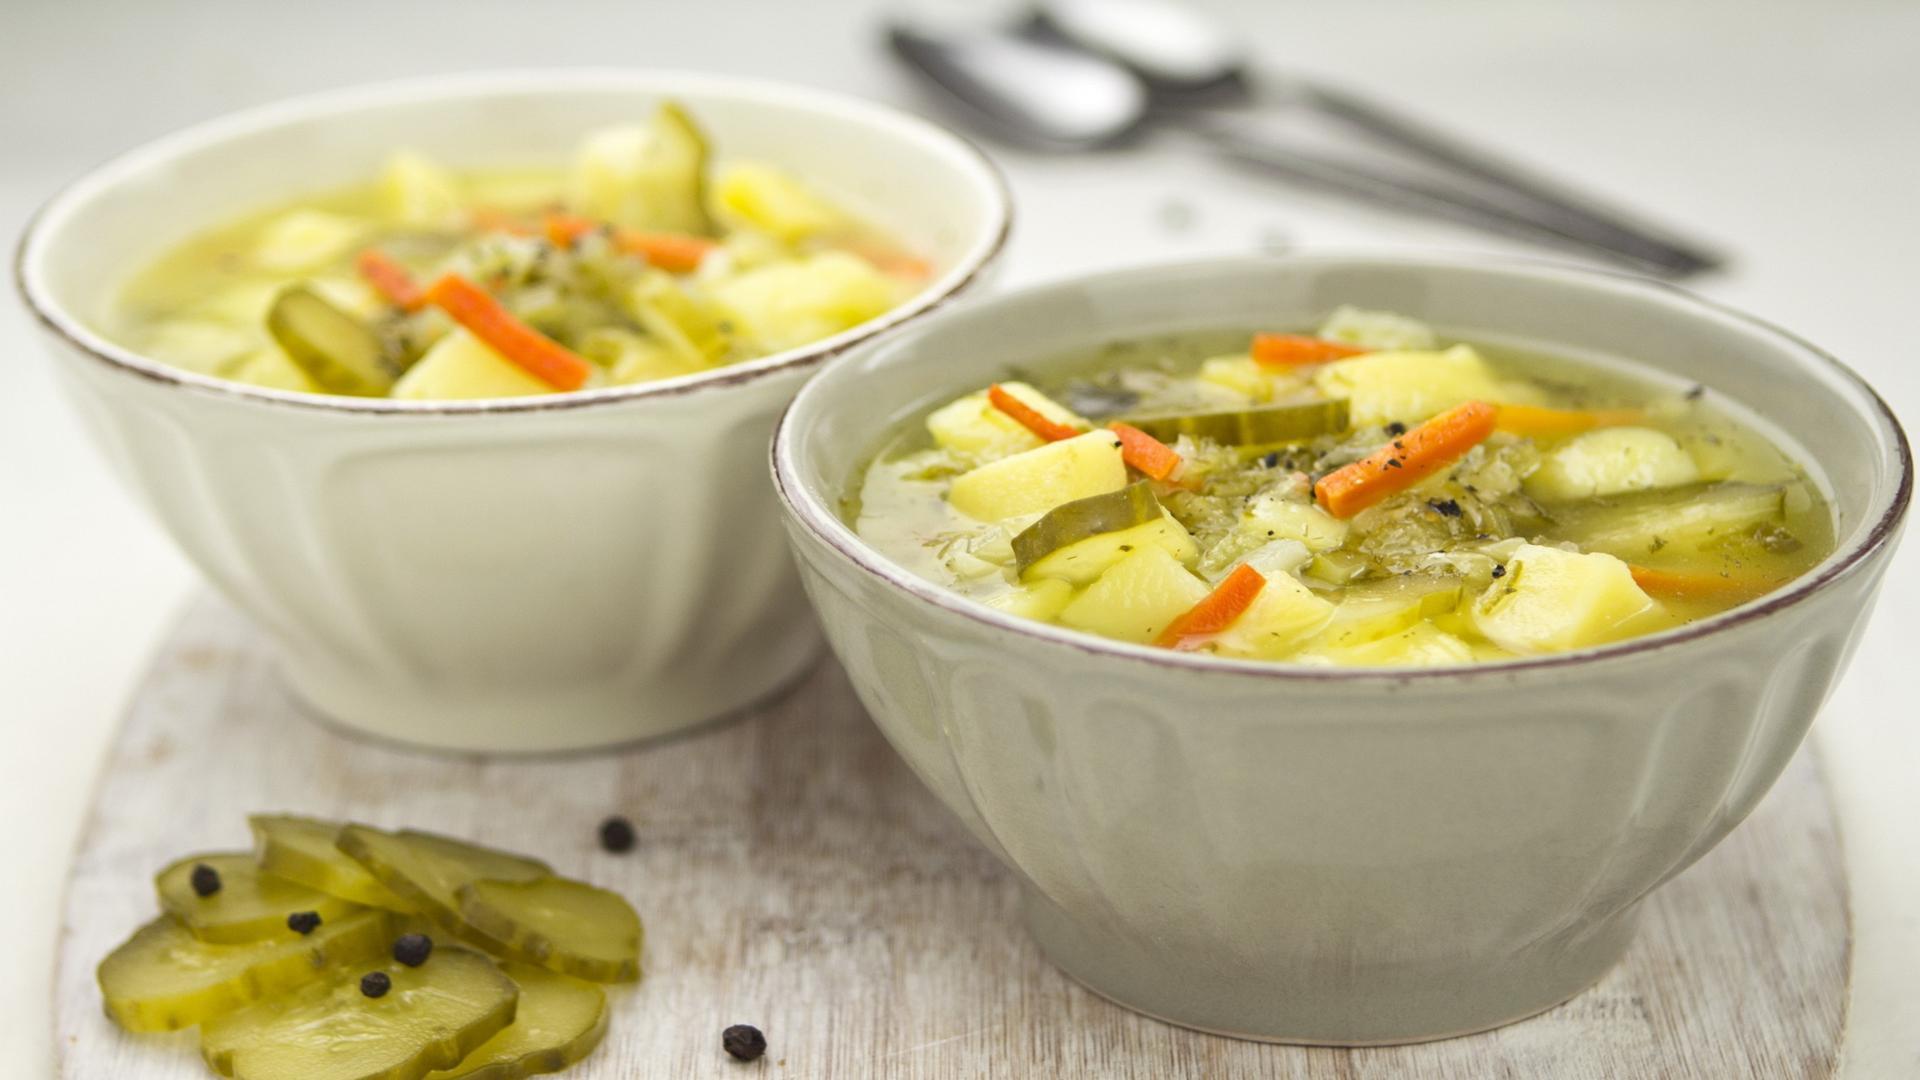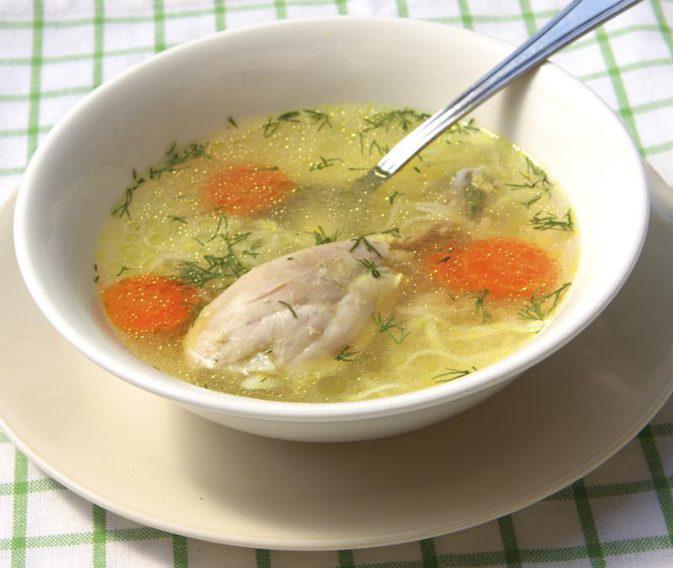The first image is the image on the left, the second image is the image on the right. Considering the images on both sides, is "A spoon is in a white bowl of chicken soup with carrots, while a second image shows two or more bowls of a different chicken soup." valid? Answer yes or no. Yes. The first image is the image on the left, the second image is the image on the right. Assess this claim about the two images: "there is a spoon in the bowl of soup". Correct or not? Answer yes or no. Yes. 